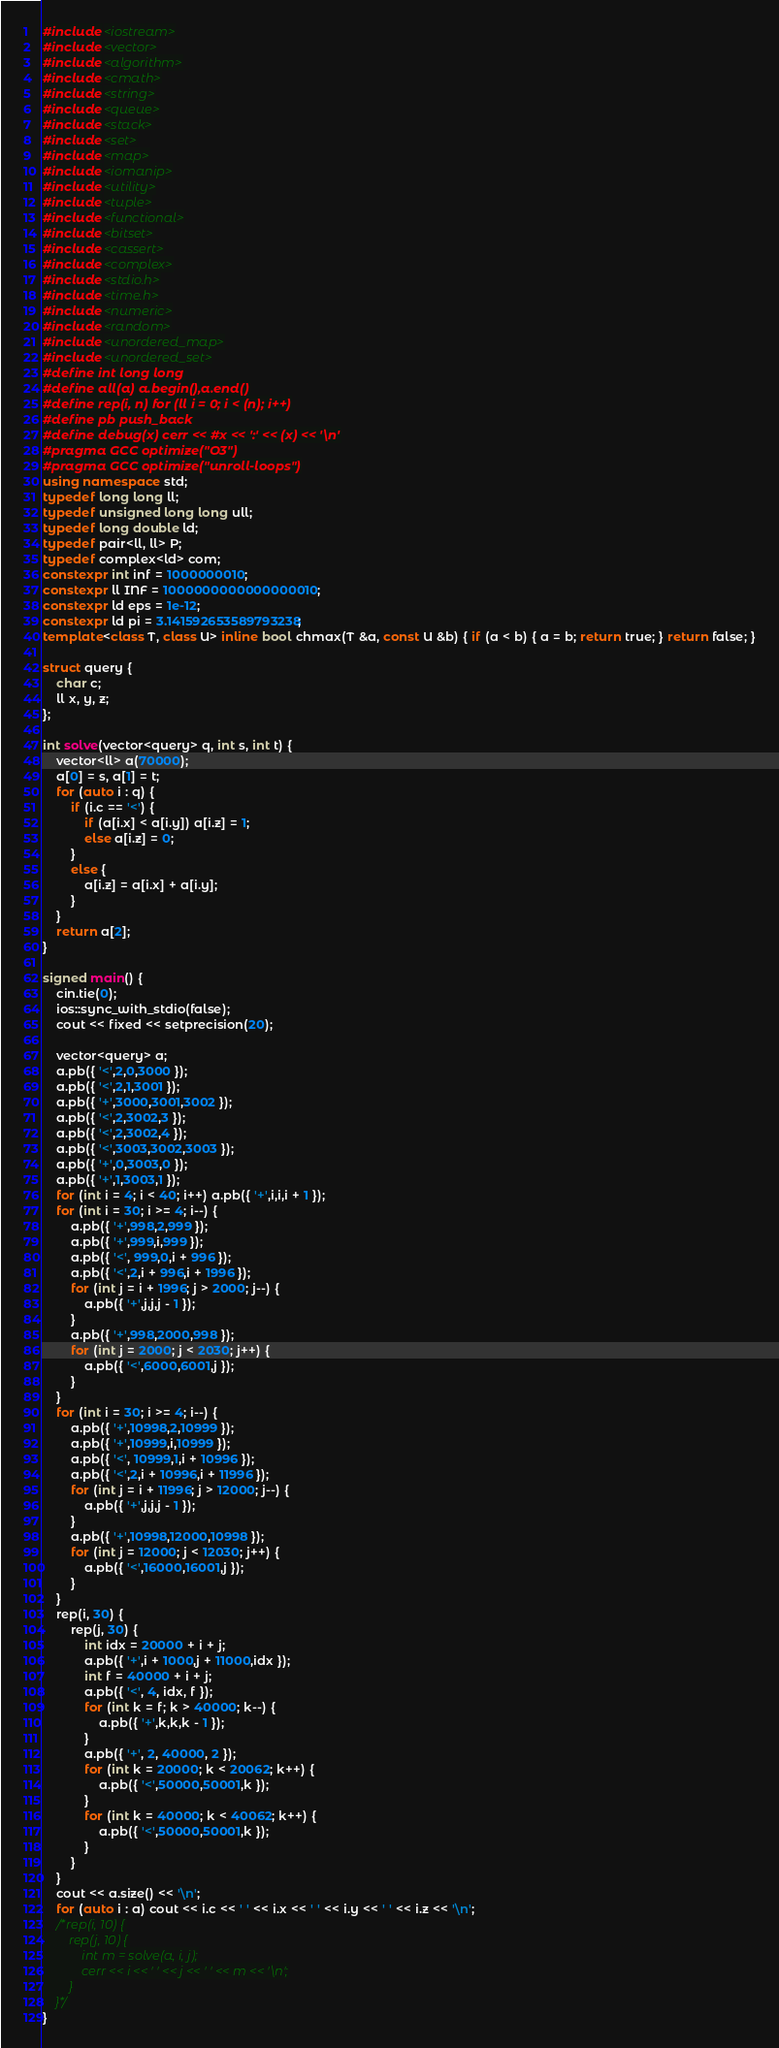<code> <loc_0><loc_0><loc_500><loc_500><_C++_>#include <iostream>
#include <vector>
#include <algorithm>
#include <cmath>
#include <string>
#include <queue>
#include <stack>
#include <set>
#include <map>
#include <iomanip>
#include <utility>
#include <tuple>
#include <functional>
#include <bitset>
#include <cassert>
#include <complex>
#include <stdio.h>
#include <time.h>
#include <numeric>
#include <random>
#include <unordered_map>
#include <unordered_set>
#define int long long
#define all(a) a.begin(),a.end()
#define rep(i, n) for (ll i = 0; i < (n); i++)
#define pb push_back
#define debug(x) cerr << #x << ':' << (x) << '\n'
#pragma GCC optimize("O3")
#pragma GCC optimize("unroll-loops")
using namespace std;
typedef long long ll;
typedef unsigned long long ull;
typedef long double ld;
typedef pair<ll, ll> P;
typedef complex<ld> com;
constexpr int inf = 1000000010;
constexpr ll INF = 1000000000000000010;
constexpr ld eps = 1e-12;
constexpr ld pi = 3.141592653589793238;
template<class T, class U> inline bool chmax(T &a, const U &b) { if (a < b) { a = b; return true; } return false; }

struct query {
	char c;
	ll x, y, z;
};

int solve(vector<query> q, int s, int t) {
	vector<ll> a(70000);
	a[0] = s, a[1] = t;
	for (auto i : q) {
		if (i.c == '<') {
			if (a[i.x] < a[i.y]) a[i.z] = 1;
			else a[i.z] = 0;
		}
		else {
			a[i.z] = a[i.x] + a[i.y];
		}
	}
	return a[2];
}

signed main() {
	cin.tie(0);
	ios::sync_with_stdio(false);
	cout << fixed << setprecision(20);

	vector<query> a;
	a.pb({ '<',2,0,3000 });
	a.pb({ '<',2,1,3001 });
	a.pb({ '+',3000,3001,3002 });
	a.pb({ '<',2,3002,3 });
	a.pb({ '<',2,3002,4 });
	a.pb({ '<',3003,3002,3003 });
	a.pb({ '+',0,3003,0 });
	a.pb({ '+',1,3003,1 });
	for (int i = 4; i < 40; i++) a.pb({ '+',i,i,i + 1 });
	for (int i = 30; i >= 4; i--) {
		a.pb({ '+',998,2,999 });
		a.pb({ '+',999,i,999 });
		a.pb({ '<', 999,0,i + 996 });
		a.pb({ '<',2,i + 996,i + 1996 });
		for (int j = i + 1996; j > 2000; j--) {
			a.pb({ '+',j,j,j - 1 });
		}
		a.pb({ '+',998,2000,998 });
		for (int j = 2000; j < 2030; j++) {
			a.pb({ '<',6000,6001,j });
		}
	}
	for (int i = 30; i >= 4; i--) {
		a.pb({ '+',10998,2,10999 });
		a.pb({ '+',10999,i,10999 });
		a.pb({ '<', 10999,1,i + 10996 });
		a.pb({ '<',2,i + 10996,i + 11996 });
		for (int j = i + 11996; j > 12000; j--) {
			a.pb({ '+',j,j,j - 1 });
		}
		a.pb({ '+',10998,12000,10998 });
		for (int j = 12000; j < 12030; j++) {
			a.pb({ '<',16000,16001,j });
		}
	}
	rep(i, 30) {
		rep(j, 30) {
			int idx = 20000 + i + j;
			a.pb({ '+',i + 1000,j + 11000,idx });
			int f = 40000 + i + j;
			a.pb({ '<', 4, idx, f });
			for (int k = f; k > 40000; k--) {
				a.pb({ '+',k,k,k - 1 });
			}
			a.pb({ '+', 2, 40000, 2 });
			for (int k = 20000; k < 20062; k++) {
				a.pb({ '<',50000,50001,k });
			}
			for (int k = 40000; k < 40062; k++) {
				a.pb({ '<',50000,50001,k });
			}
		}
	}
	cout << a.size() << '\n';
	for (auto i : a) cout << i.c << ' ' << i.x << ' ' << i.y << ' ' << i.z << '\n';
	/*rep(i, 10) {
		rep(j, 10) {
			int m = solve(a, i, j);
			cerr << i << ' ' << j << ' ' << m << '\n';
		}
	}*/
}</code> 